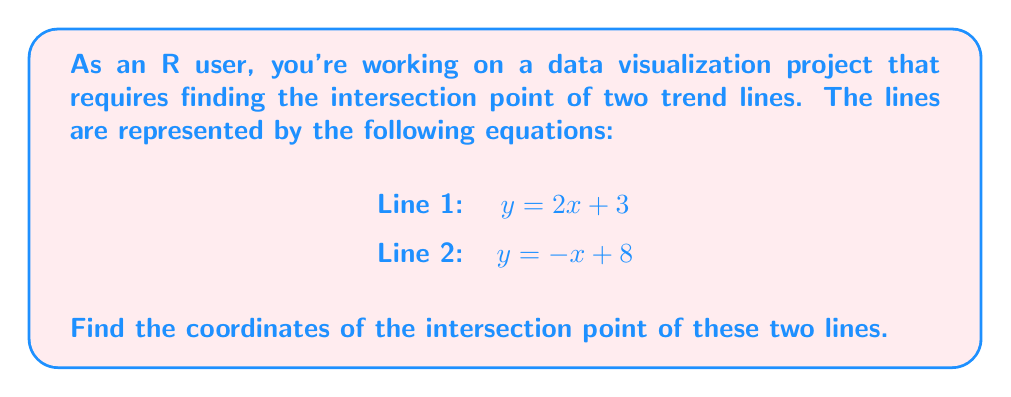Solve this math problem. To find the intersection point of two lines, we need to solve the system of equations formed by their equations. Let's approach this step-by-step:

1. We have two equations:
   $$y = 2x + 3$$ (Line 1)
   $$y = -x + 8$$ (Line 2)

2. At the intersection point, the $x$ and $y$ coordinates will be the same for both lines. So, we can set the right sides of the equations equal to each other:

   $$2x + 3 = -x + 8$$

3. Now, let's solve this equation for $x$:
   
   $$2x + 3 = -x + 8$$
   $$3x = 5$$
   $$x = \frac{5}{3}$$

4. Now that we know the $x$-coordinate of the intersection point, we can substitute this value into either of the original equations to find the $y$-coordinate. Let's use the equation of Line 1:

   $$y = 2x + 3$$
   $$y = 2(\frac{5}{3}) + 3$$
   $$y = \frac{10}{3} + 3$$
   $$y = \frac{10}{3} + \frac{9}{3}$$
   $$y = \frac{19}{3}$$

5. Therefore, the coordinates of the intersection point are $(\frac{5}{3}, \frac{19}{3})$.

In R, you could verify this result using the following code:

```R
x <- 5/3
y1 <- 2*x + 3
y2 <- -x + 8
print(c(x, y1))
print(c(x, y2))
```

This should output the same coordinates for both lines, confirming the intersection point.
Answer: The intersection point of the two lines is $(\frac{5}{3}, \frac{19}{3})$. 